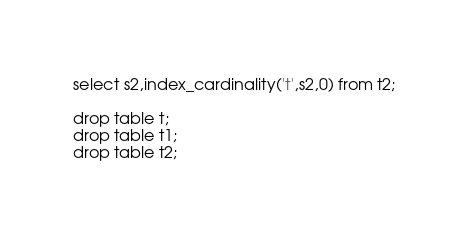<code> <loc_0><loc_0><loc_500><loc_500><_SQL_>select s2,index_cardinality('t',s2,0) from t2;

drop table t;
drop table t1;
drop table t2;

</code> 